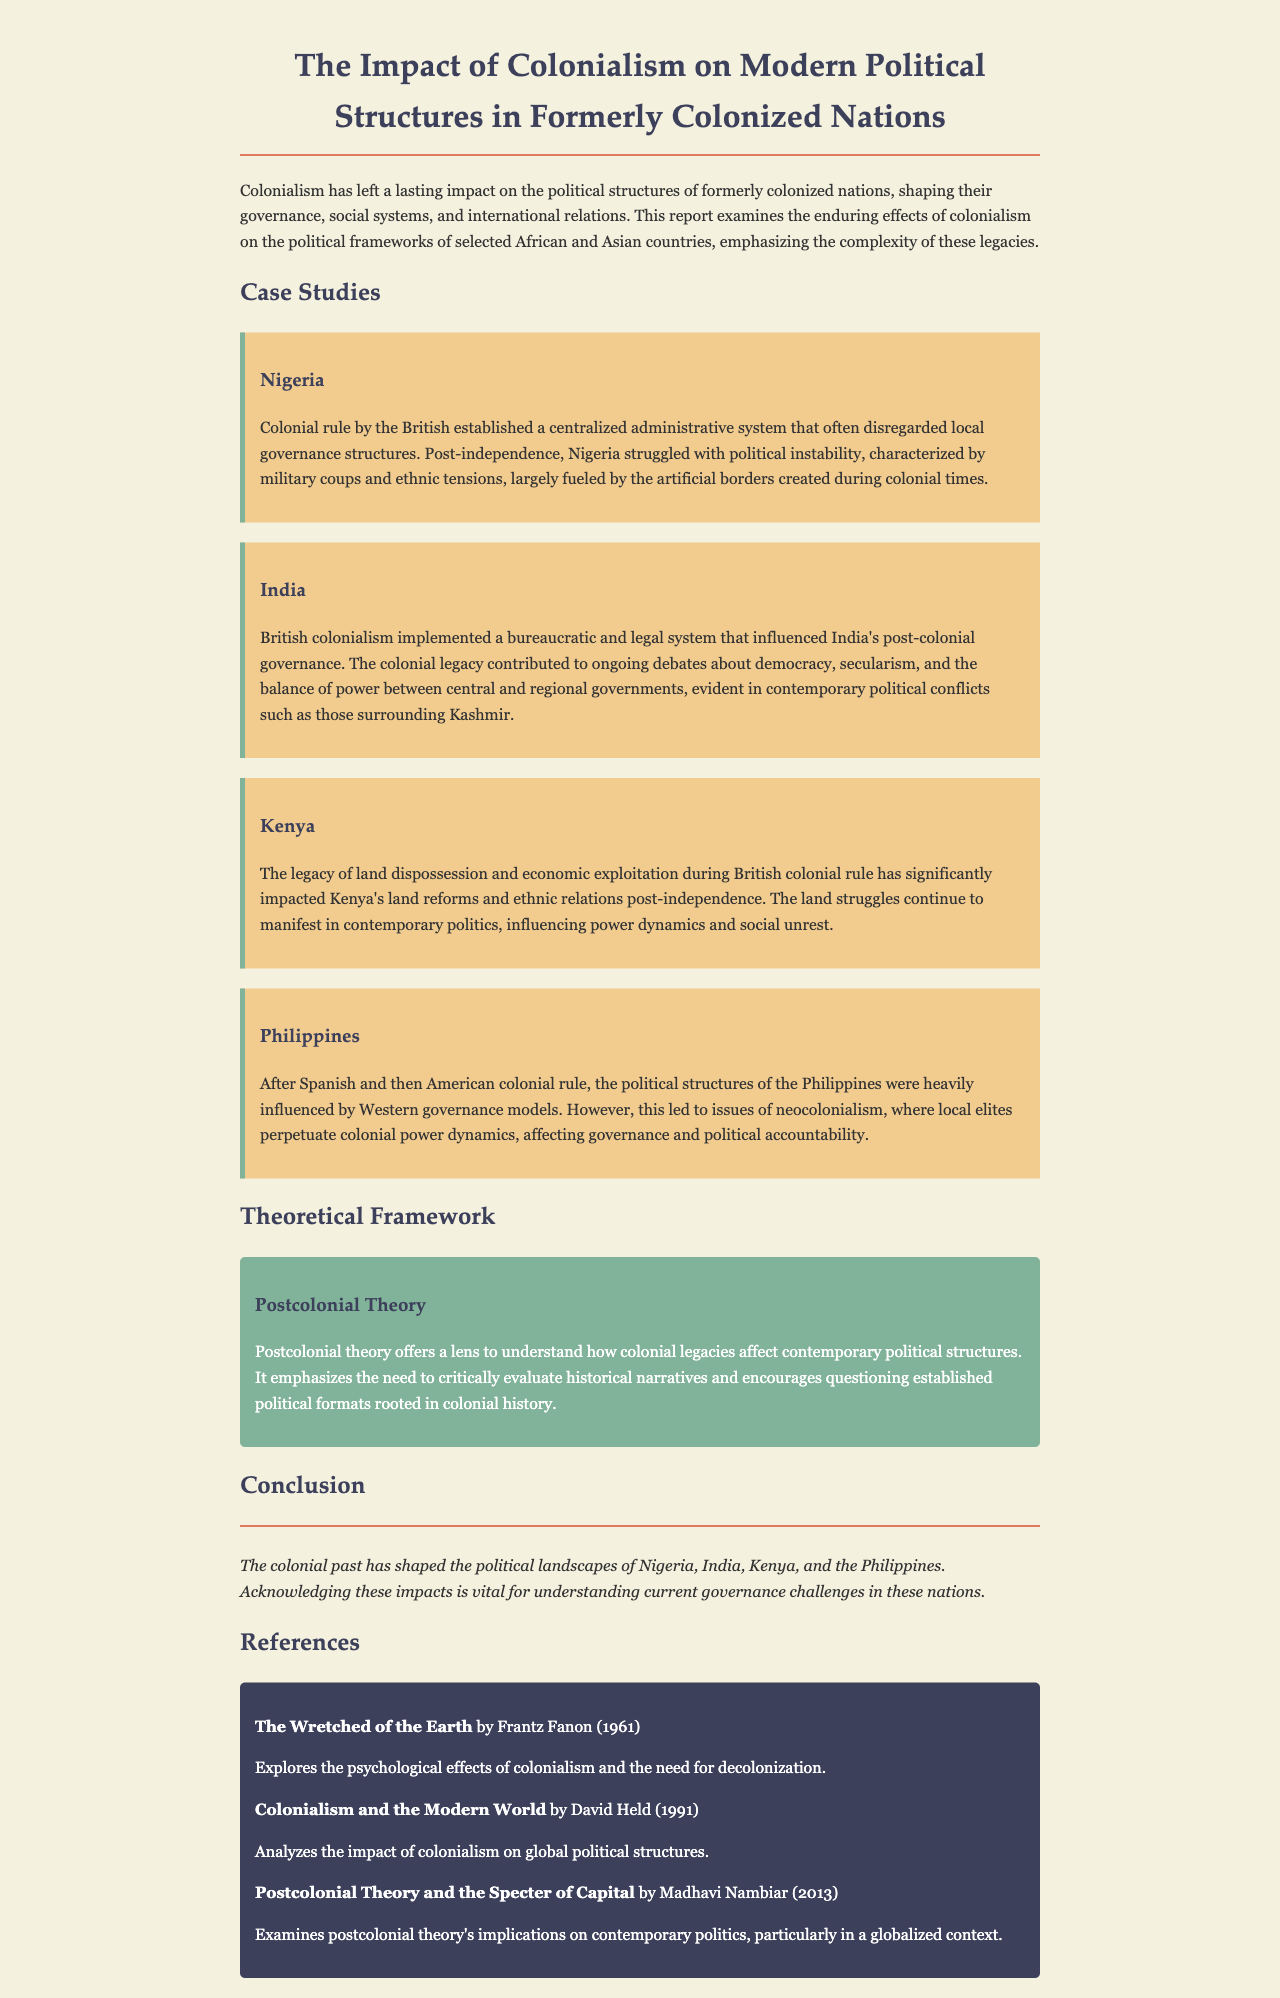What is the title of the report? The title is prominently displayed at the top of the document, reflecting the main subject discussed.
Answer: The Impact of Colonialism on Modern Political Structures in Formerly Colonized Nations Which case study discusses ethnic tensions? The case studies present specific countries affected by colonialism, with Nigeria highlighted for its ethnic tensions.
Answer: Nigeria Who authored "The Wretched of the Earth"? The author of this significant work is mentioned in the references section, showcasing a prominent voice in postcolonial discourse.
Answer: Frantz Fanon What legacy impacted Kenya's land reforms? The document details the consequences of colonial actions on current political issues, specifically noting land dispossession as a key factor in Kenya.
Answer: Land dispossession What theoretical lens is used to analyze colonial legacies? The document introduces this framework in the theoretical section, emphasizing its importance for understanding modern politics.
Answer: Postcolonial Theory How many case studies are provided in the document? The report specifies the number of countries addressed in the case studies section, indicating the diversity of examples.
Answer: Four What color scheme is used for case studies? The document describes the aesthetic choices made for different sections, including a specific background color for case studies.
Answer: Light yellow In which year was "Postcolonial Theory and the Specter of Capital" published? The references include specific publication years for each cited work, which helps situate the scholarly context.
Answer: 2013 